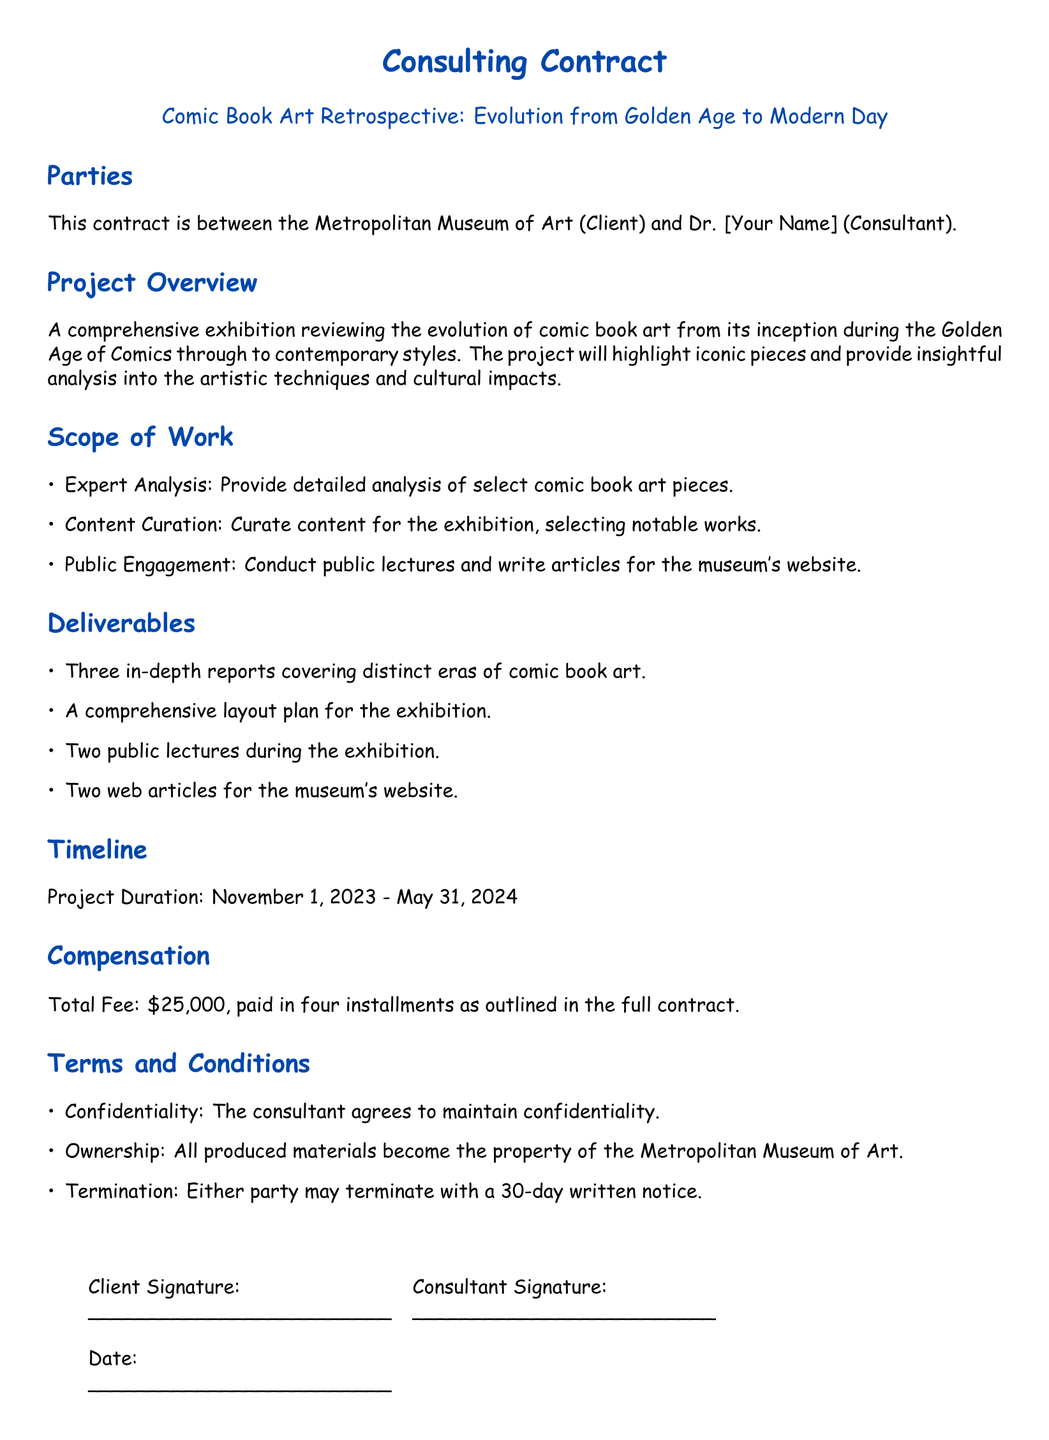What is the name of the client? The client mentioned in the contract is the Metropolitan Museum of Art.
Answer: Metropolitan Museum of Art Who is the consultant? The document introduces the consultant as Dr. [Your Name].
Answer: Dr. [Your Name] What is the total fee for the consulting services? The total fee as stated in the contract is $25,000.
Answer: $25,000 What are the project start and end dates? The project duration is specified as November 1, 2023 - May 31, 2024.
Answer: November 1, 2023 - May 31, 2024 How many public lectures will the consultant conduct? The document states that there will be two public lectures during the exhibition.
Answer: Two What is one of the responsibilities under the scope of work? One responsibility listed is to provide detailed analysis of select comic book art pieces.
Answer: Provide detailed analysis What happens to the produced materials? According to the terms, all produced materials become the property of the Metropolitan Museum of Art.
Answer: Become the property of the Metropolitan Museum of Art What must be included in the termination notice? The termination clause requires a 30-day written notice from either party.
Answer: 30-day written notice What is one deliverable mentioned in the document? A comprehensive layout plan for the exhibition is mentioned as a deliverable.
Answer: Comprehensive layout plan 